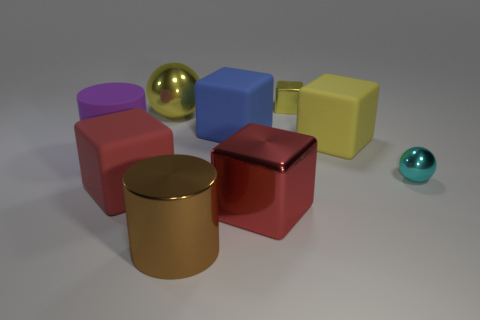Can you describe the lighting and shadows in the image? The lighting in the image appears soft and diffused, casting gentle shadows behind the objects on the right, suggesting an ambient light source positioned to the top left of the scene. 